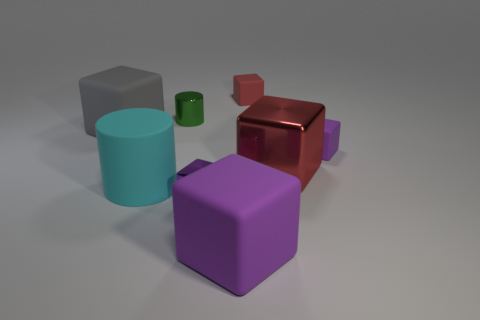There is a purple cube that is behind the purple metallic object that is in front of the red cube in front of the large gray matte cube; what is it made of?
Your answer should be compact. Rubber. How many purple matte blocks are the same size as the gray thing?
Your answer should be very brief. 1. There is a tiny object that is both to the left of the tiny red object and in front of the small green cylinder; what is its material?
Offer a terse response. Metal. There is a gray block; how many objects are in front of it?
Provide a succinct answer. 5. There is a cyan object; does it have the same shape as the small metal object that is behind the big gray rubber block?
Give a very brief answer. Yes. Are there any small purple metal things that have the same shape as the big red metallic object?
Ensure brevity in your answer.  Yes. The large thing that is behind the small matte thing in front of the small cylinder is what shape?
Keep it short and to the point. Cube. What shape is the matte thing that is behind the metal cylinder?
Your response must be concise. Cube. There is a large matte block behind the small purple rubber object; is its color the same as the tiny matte object in front of the tiny red cube?
Ensure brevity in your answer.  No. How many things are left of the small cylinder and right of the big metallic block?
Keep it short and to the point. 0. 